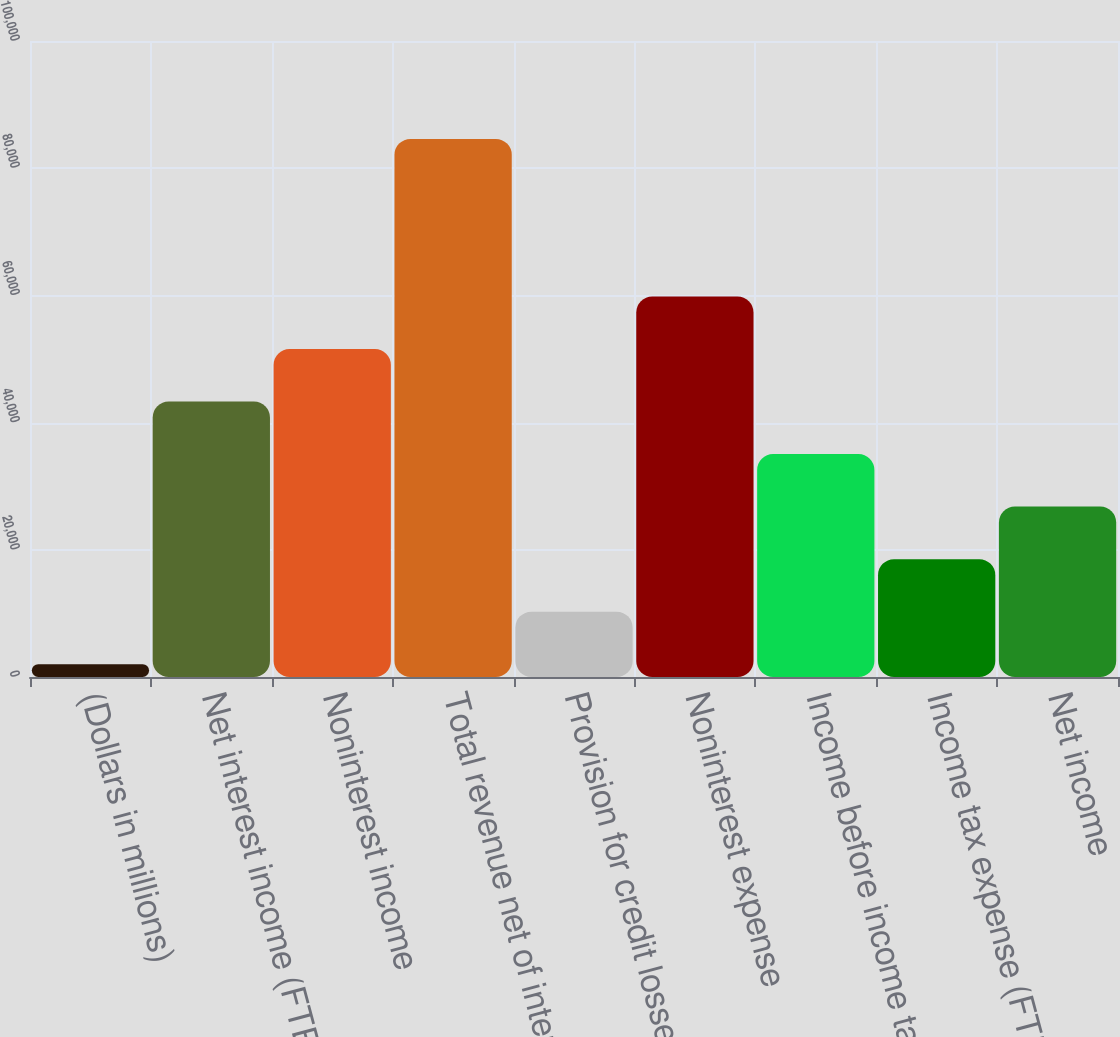Convert chart to OTSL. <chart><loc_0><loc_0><loc_500><loc_500><bar_chart><fcel>(Dollars in millions)<fcel>Net interest income (FTE<fcel>Noninterest income<fcel>Total revenue net of interest<fcel>Provision for credit losses<fcel>Noninterest expense<fcel>Income before income taxes<fcel>Income tax expense (FTE basis)<fcel>Net income<nl><fcel>2016<fcel>43308.5<fcel>51567<fcel>84601<fcel>10274.5<fcel>59825.5<fcel>35050<fcel>18533<fcel>26791.5<nl></chart> 